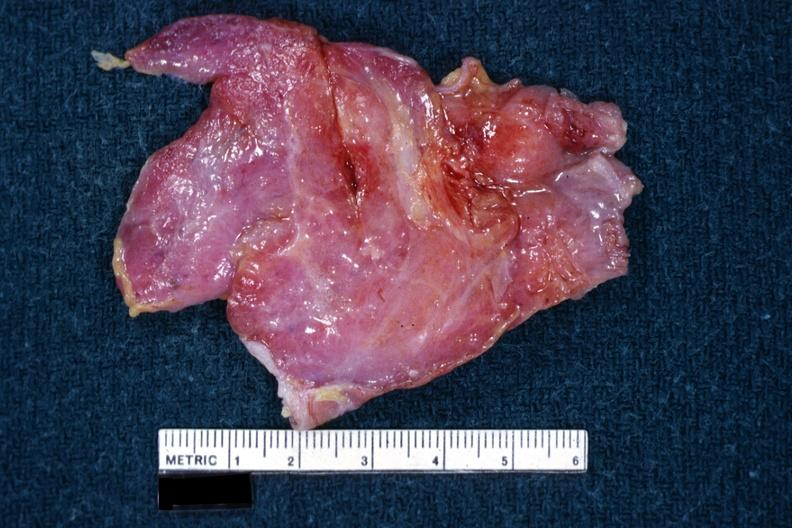does exostosis show i am not sure of diagnosis?
Answer the question using a single word or phrase. No 